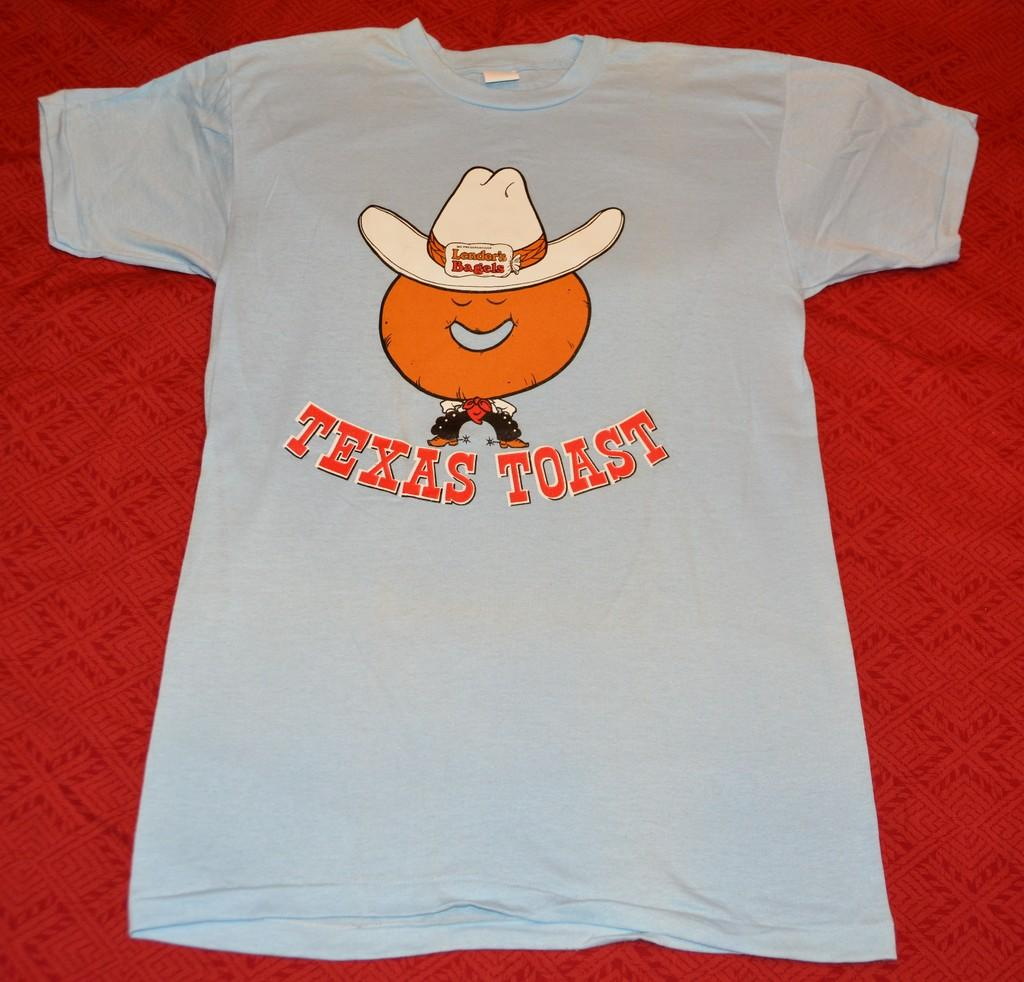What type of clothing item is in the image? There is a T-shirt in the image. How is the T-shirt positioned in the image? The T-shirt is placed on a red cloth. What color is the T-shirt? The T-shirt is white in color. What text is printed on the T-shirt? The name "Texas toast" is printed on the T-shirt. How many feathers are attached to the T-shirt in the image? There are no feathers attached to the T-shirt in the image. What type of show is being advertised on the T-shirt? The T-shirt does not advertise a show; it has the name "Texas toast" printed on it. 